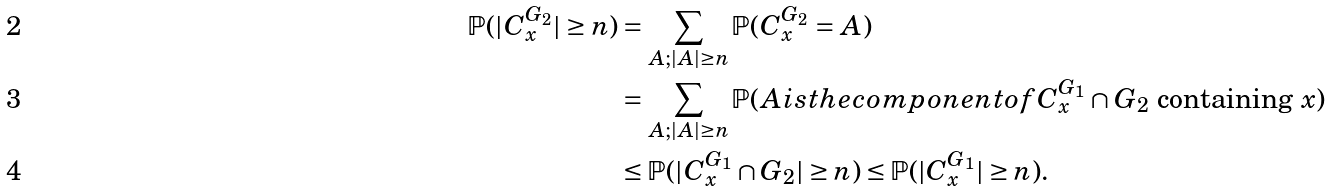<formula> <loc_0><loc_0><loc_500><loc_500>\mathbb { P } ( | C _ { x } ^ { G _ { 2 } } | \geq n ) & = \sum _ { A ; | A | \geq n } \mathbb { P } ( C _ { x } ^ { G _ { 2 } } = A ) \\ & = \sum _ { A ; | A | \geq n } \mathbb { P } ( A i s t h e c o m p o n e n t o f C _ { x } ^ { G _ { 1 } } \cap G _ { 2 } \text { containing } x ) \\ & \leq \mathbb { P } ( | C _ { x } ^ { G _ { 1 } } \cap G _ { 2 } | \geq n ) \leq \mathbb { P } ( | C _ { x } ^ { G _ { 1 } } | \geq n ) .</formula> 